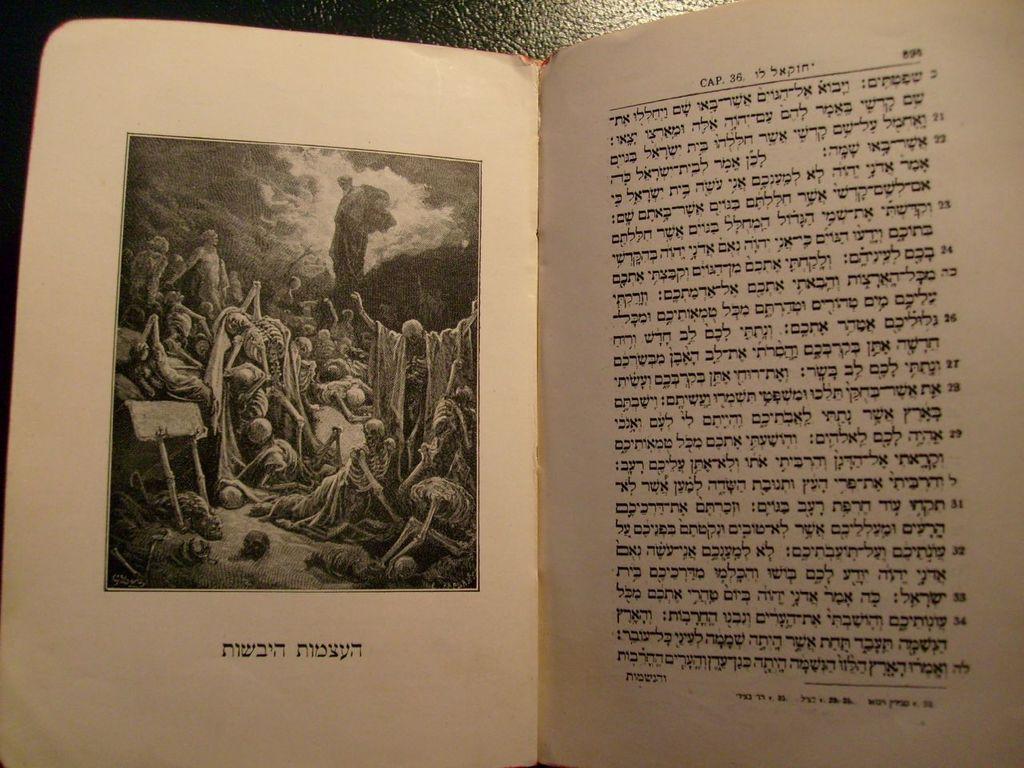Could you give a brief overview of what you see in this image? In this image we can see one on the surface, some text and numbers in this book, one image on this book page, some people, and so many objects are on this image. At the top there is the sky in this image. 